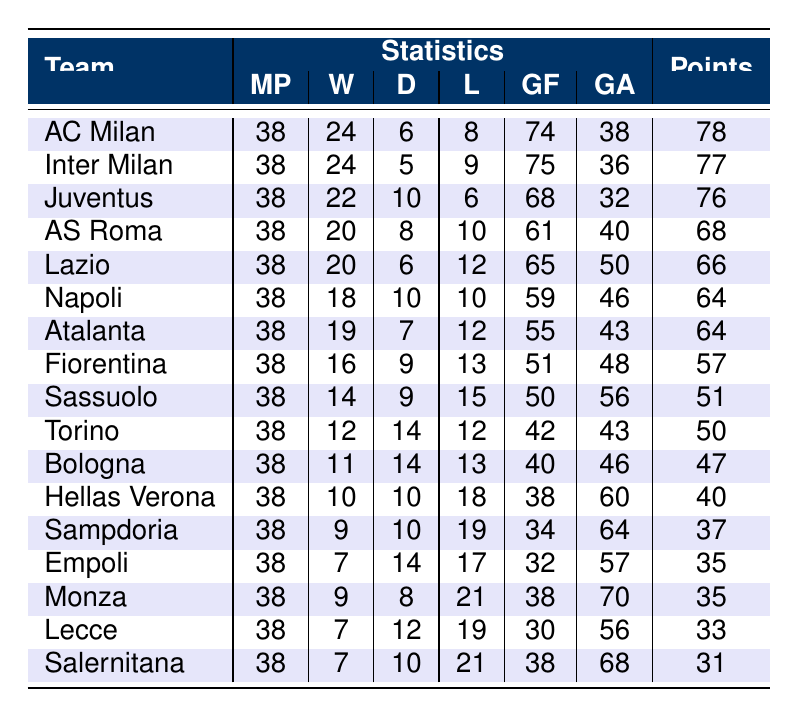What team had the highest number of wins in the Serie A season 2022-2023? By reviewing the "Wins" column in the table, both AC Milan and Inter Milan have 24 wins, which are the highest among all teams.
Answer: AC Milan and Inter Milan How many goals did Juventus score during the season? Looking at the "Goals For" column for Juventus, it shows a value of 68.
Answer: 68 Which team had the fewest points in the table? The "Points" column indicates that Salernitana has the lowest points total at 31.
Answer: 31 What is the goal difference for AS Roma? The goal difference can be calculated by subtracting the "Goals Against" (40) from "Goals For" (61), resulting in 21.
Answer: 21 Did any team have more than 20 wins in the season? Checking the "Wins" column, AC Milan, Inter Milan, and Juventus all exceed 20 wins, confirming that multiple teams had more than 20 wins.
Answer: Yes What is the average number of goals scored by teams that finished in the top three? The top three teams are AC Milan (74), Inter Milan (75), and Juventus (68). Their total goals scored is 74 + 75 + 68 = 217, and there are 3 teams; thus, the average is 217/3 = 72.33.
Answer: 72.33 Which team had the most losses? Examining the "Losses" column, Monza had the most losses with a total of 21.
Answer: Monza If a team has more draws than wins, which team qualifies? Analyzing the table, Bologna (11 wins, 14 draws) and Torino (12 wins, 14 draws) both have more draws than wins.
Answer: Bologna and Torino How many teams had at least 60 goals against them? Looking at the "Goals Against" column, teams with 60 or more goals against are Hellas Verona (60), Sampdoria (64), Monza (70), and Salernitana (68), totaling 4 teams.
Answer: 4 What was the total number of points accumulated by teams ranked 4th to 6th? The points for AS Roma (68), Lazio (66), and Napoli (64) are summed: 68 + 66 + 64 = 198.
Answer: 198 